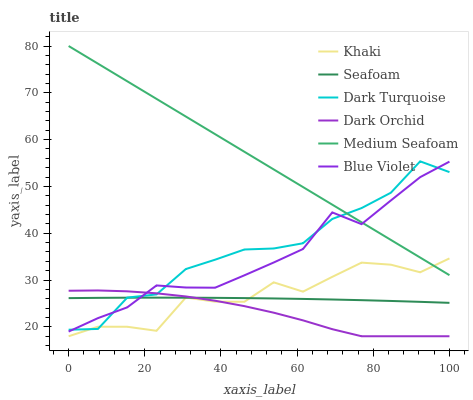Does Dark Orchid have the minimum area under the curve?
Answer yes or no. Yes. Does Medium Seafoam have the maximum area under the curve?
Answer yes or no. Yes. Does Dark Turquoise have the minimum area under the curve?
Answer yes or no. No. Does Dark Turquoise have the maximum area under the curve?
Answer yes or no. No. Is Medium Seafoam the smoothest?
Answer yes or no. Yes. Is Khaki the roughest?
Answer yes or no. Yes. Is Dark Turquoise the smoothest?
Answer yes or no. No. Is Dark Turquoise the roughest?
Answer yes or no. No. Does Dark Turquoise have the lowest value?
Answer yes or no. No. Does Dark Turquoise have the highest value?
Answer yes or no. No. Is Dark Orchid less than Medium Seafoam?
Answer yes or no. Yes. Is Blue Violet greater than Khaki?
Answer yes or no. Yes. Does Dark Orchid intersect Medium Seafoam?
Answer yes or no. No. 